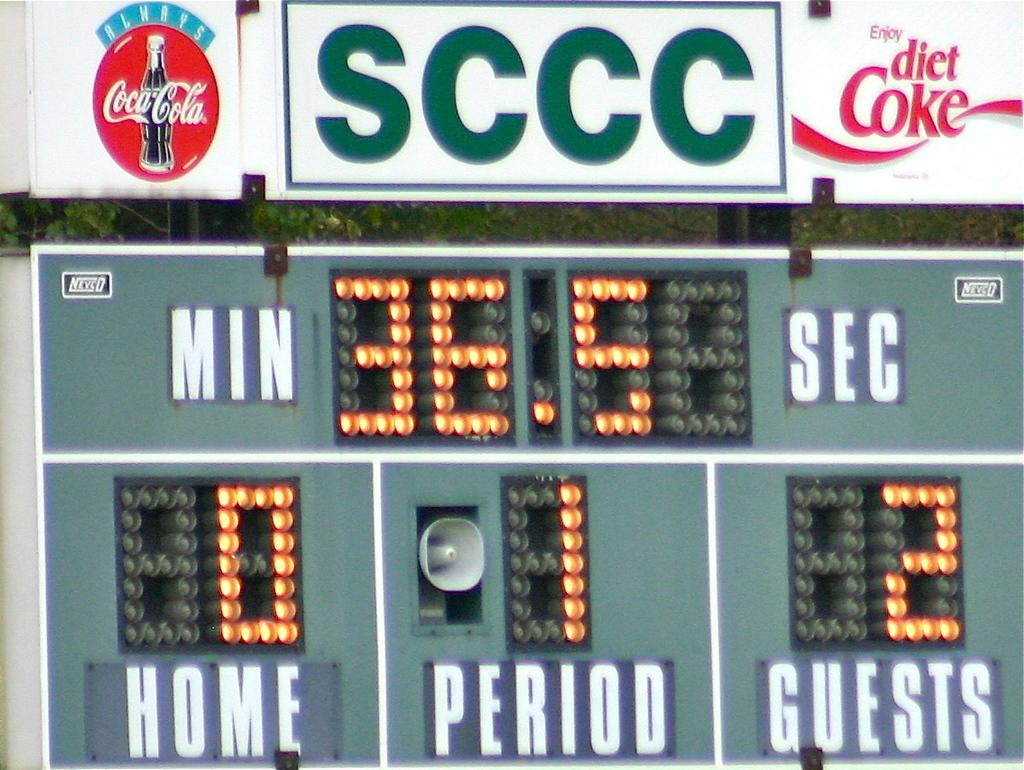<image>
Write a terse but informative summary of the picture. A scoreboard for a teams game and has coca-cola ads on it 